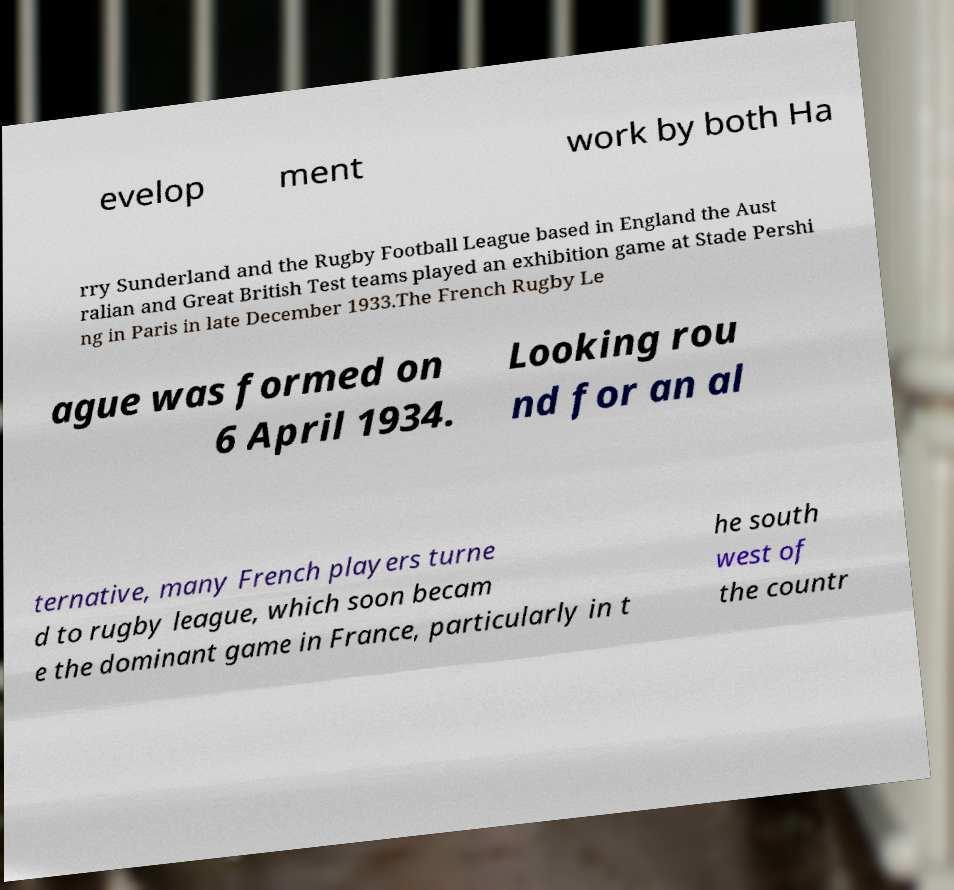Can you read and provide the text displayed in the image?This photo seems to have some interesting text. Can you extract and type it out for me? evelop ment work by both Ha rry Sunderland and the Rugby Football League based in England the Aust ralian and Great British Test teams played an exhibition game at Stade Pershi ng in Paris in late December 1933.The French Rugby Le ague was formed on 6 April 1934. Looking rou nd for an al ternative, many French players turne d to rugby league, which soon becam e the dominant game in France, particularly in t he south west of the countr 